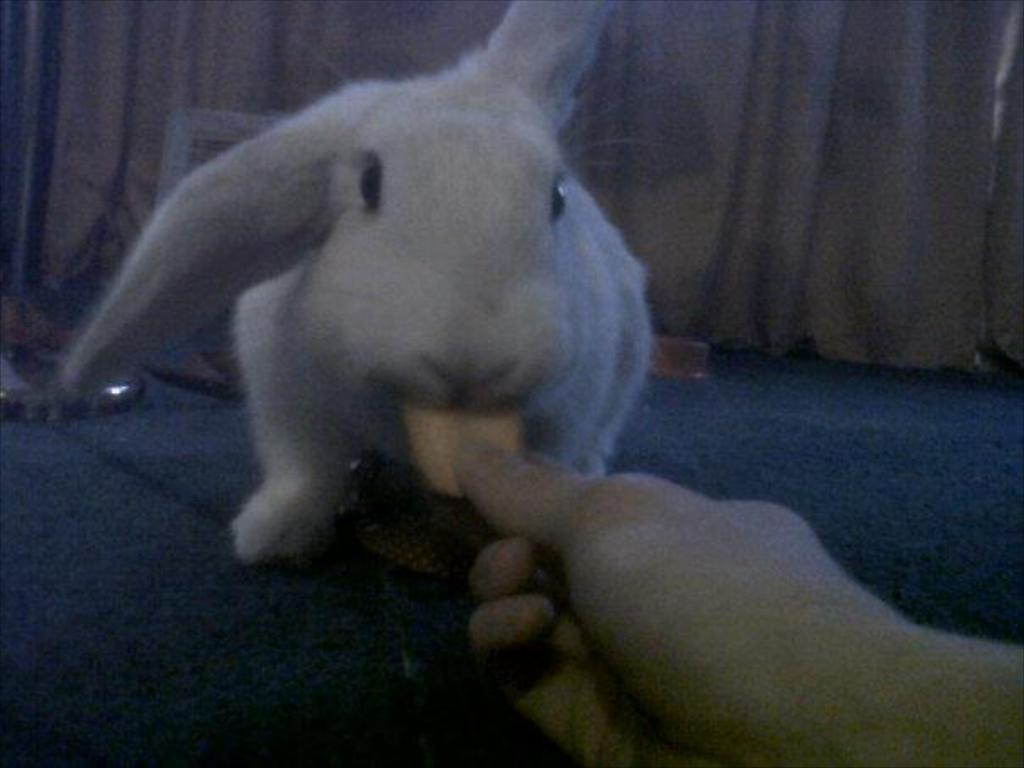What animal is present in the image? There is a white rabbit in the image. What is the person in the image doing? The person is feeding the rabbit. What can be seen behind the rabbit? There is a curtain behind the rabbit. What hobbies does the silver thing in the image enjoy? There is no silver thing present in the image, so it's not possible to determine its hobbies. 